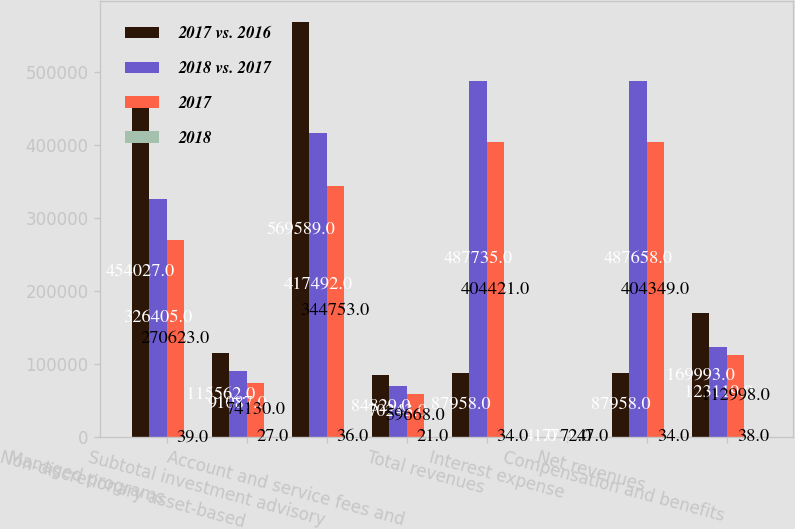Convert chart to OTSL. <chart><loc_0><loc_0><loc_500><loc_500><stacked_bar_chart><ecel><fcel>Managed programs<fcel>Non-discretionary asset-based<fcel>Subtotal investment advisory<fcel>Account and service fees and<fcel>Total revenues<fcel>Interest expense<fcel>Net revenues<fcel>Compensation and benefits<nl><fcel>2017 vs. 2016<fcel>454027<fcel>115562<fcel>569589<fcel>84829<fcel>87958<fcel>41<fcel>87958<fcel>169993<nl><fcel>2018 vs. 2017<fcel>326405<fcel>91087<fcel>417492<fcel>70243<fcel>487735<fcel>77<fcel>487658<fcel>123119<nl><fcel>2017<fcel>270623<fcel>74130<fcel>344753<fcel>59668<fcel>404421<fcel>72<fcel>404349<fcel>112998<nl><fcel>2018<fcel>39<fcel>27<fcel>36<fcel>21<fcel>34<fcel>47<fcel>34<fcel>38<nl></chart> 